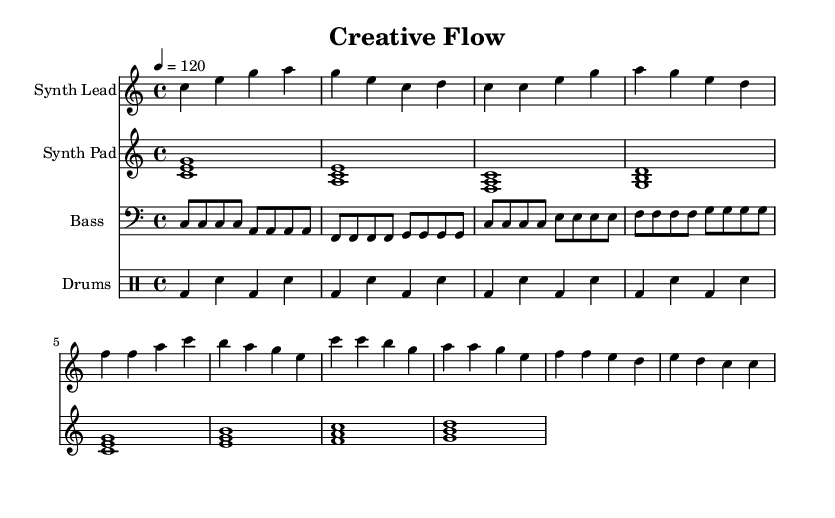What is the key signature of this music? The key signature shown is C major, which is indicated by the absence of any sharps or flats.
Answer: C major What is the time signature of the piece? The time signature is indicated as 4/4, meaning there are four beats in a measure and a quarter note receives one beat.
Answer: 4/4 What is the tempo marking for this piece? The tempo marking indicates a speed of 120 beats per minute, expressed as "4 = 120" in the score.
Answer: 120 What instrument plays the synth lead? The instrument labeled at the beginning of the staff for the synth lead part is "Synth Lead."
Answer: Synth Lead In which section do the bass notes change pattern? The bass notes change pattern in the measure containing the notes that follow the initial eight measures, specifically when it transitions from repetition of "c" to "e" notes.
Answer: After eight measures How many unique chords are used in the synth pad part? The synth pad section features a sequence of unique chords, which includes four distinct chords in the first eight measures. They are C major, A minor, F major, and G major.
Answer: Four What rhythmic pattern is primarily used in the drums part? The rhythmic pattern prominently used in the drums part is a four-on-the-floor beat, characterized by a bass drum playing on every beat in the measure.
Answer: Four-on-the-floor 